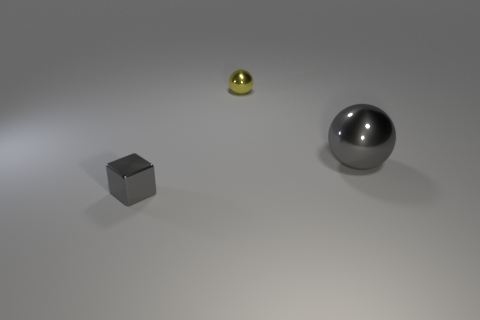Are there any tiny yellow metallic blocks?
Ensure brevity in your answer.  No. Is the number of large shiny things that are behind the small gray object greater than the number of small gray cubes on the right side of the big gray metallic thing?
Your answer should be very brief. Yes. The object that is in front of the yellow sphere and to the left of the large thing is made of what material?
Make the answer very short. Metal. Is the shape of the tiny yellow metallic thing the same as the big gray metal object?
Make the answer very short. Yes. Are there any other things that are the same size as the shiny cube?
Offer a very short reply. Yes. What number of tiny gray objects are behind the tiny yellow thing?
Your response must be concise. 0. Does the sphere on the right side of the yellow shiny thing have the same size as the small gray block?
Your answer should be very brief. No. What is the color of the other big metal thing that is the same shape as the yellow metallic thing?
Provide a short and direct response. Gray. Is there anything else that has the same shape as the small gray thing?
Give a very brief answer. No. What is the shape of the thing in front of the large metal thing?
Provide a short and direct response. Cube. 